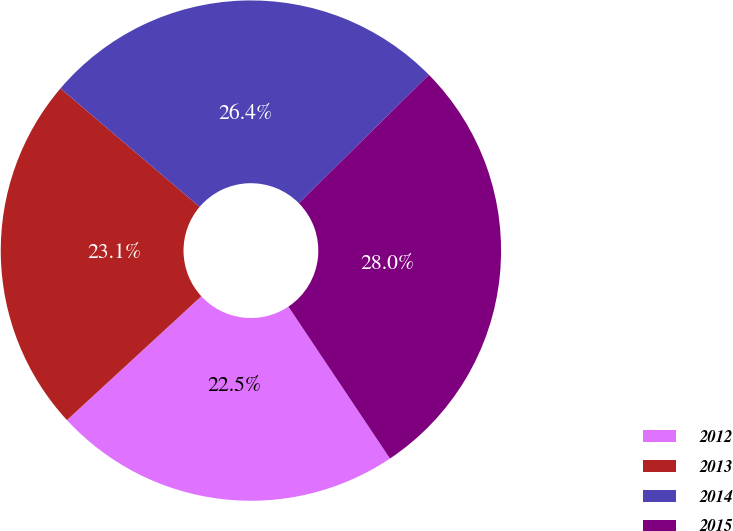Convert chart to OTSL. <chart><loc_0><loc_0><loc_500><loc_500><pie_chart><fcel>2012<fcel>2013<fcel>2014<fcel>2015<nl><fcel>22.53%<fcel>23.08%<fcel>26.37%<fcel>28.02%<nl></chart> 